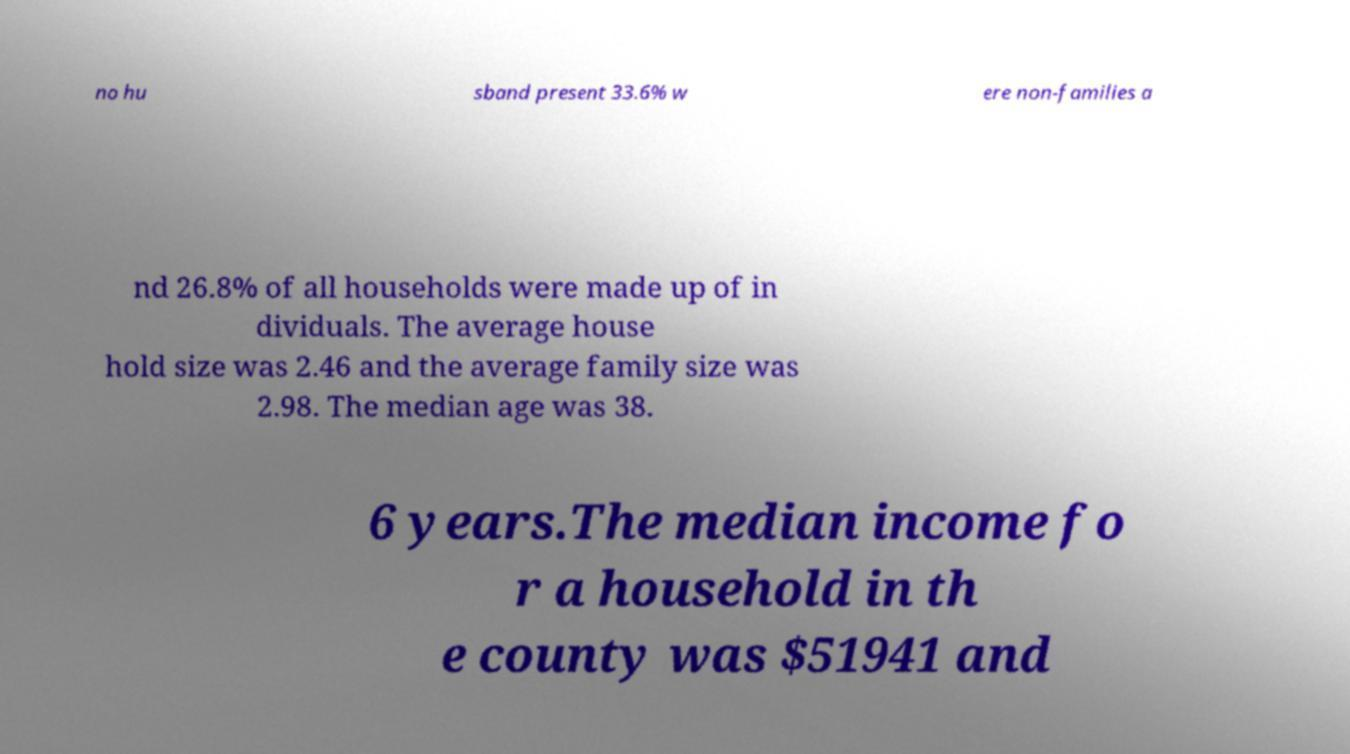What messages or text are displayed in this image? I need them in a readable, typed format. no hu sband present 33.6% w ere non-families a nd 26.8% of all households were made up of in dividuals. The average house hold size was 2.46 and the average family size was 2.98. The median age was 38. 6 years.The median income fo r a household in th e county was $51941 and 